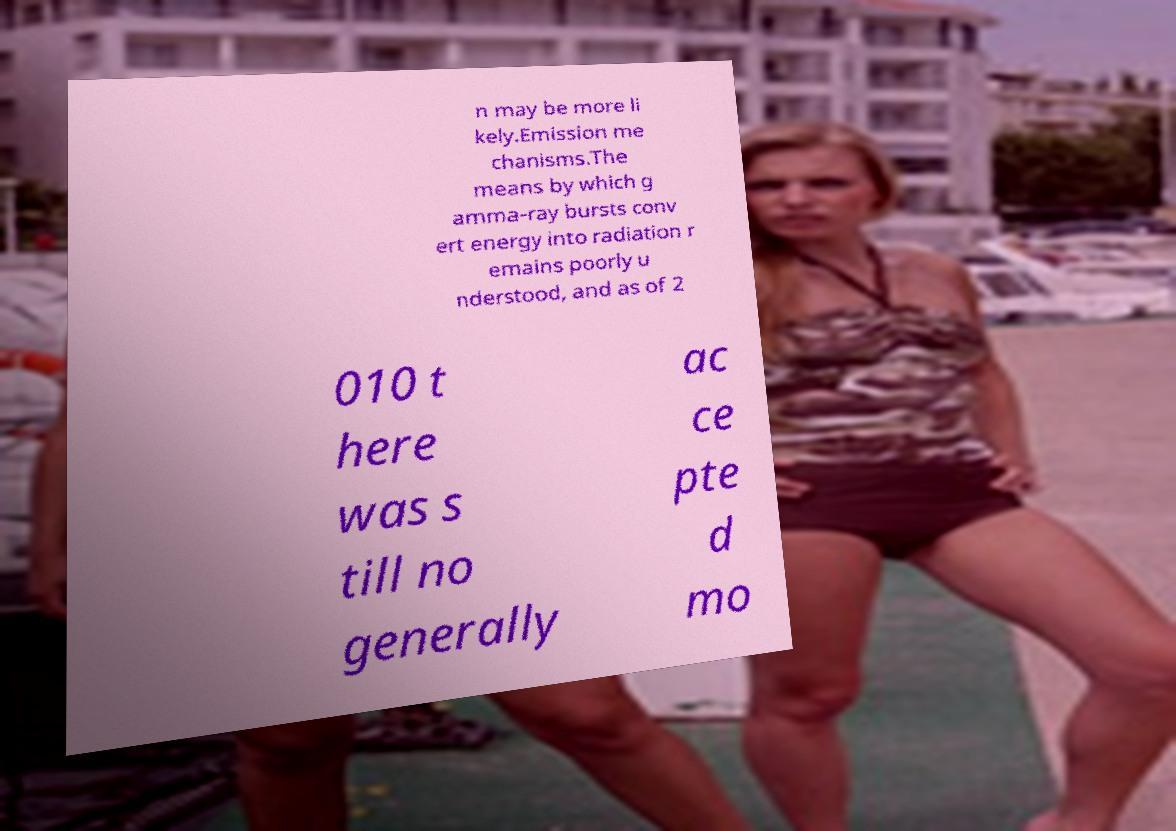Can you accurately transcribe the text from the provided image for me? n may be more li kely.Emission me chanisms.The means by which g amma-ray bursts conv ert energy into radiation r emains poorly u nderstood, and as of 2 010 t here was s till no generally ac ce pte d mo 